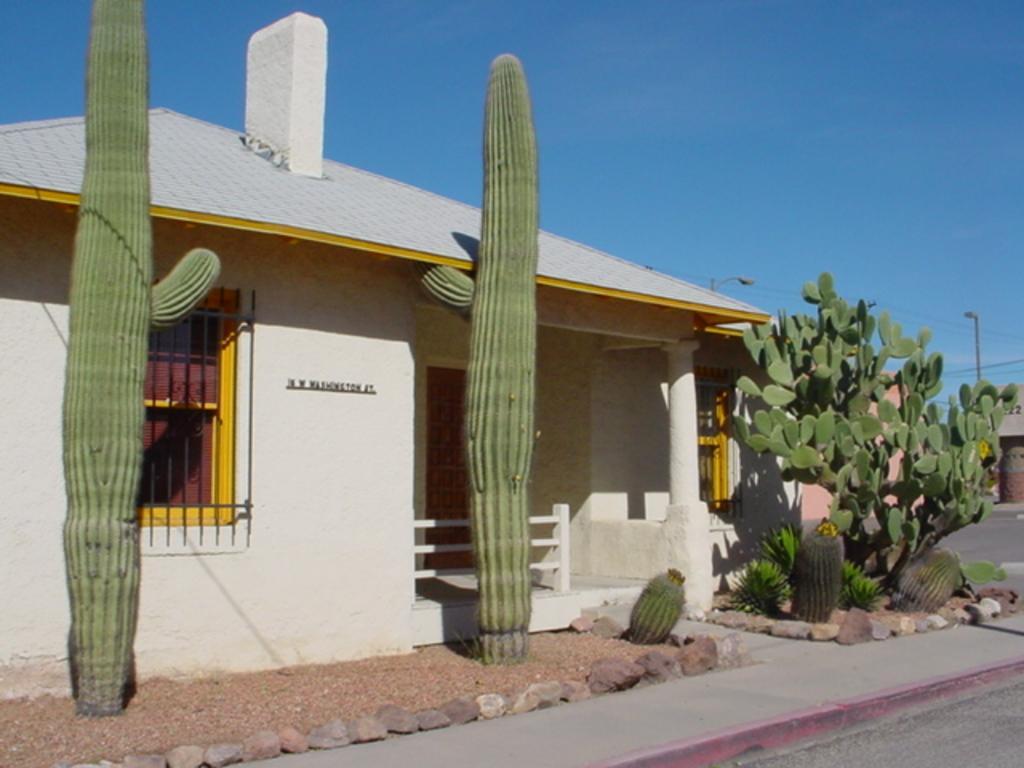Please provide a concise description of this image. In this image I can see the house with windows. In-front of the house there are plants and the stones. In the background I can see the pole and the blue sky. 